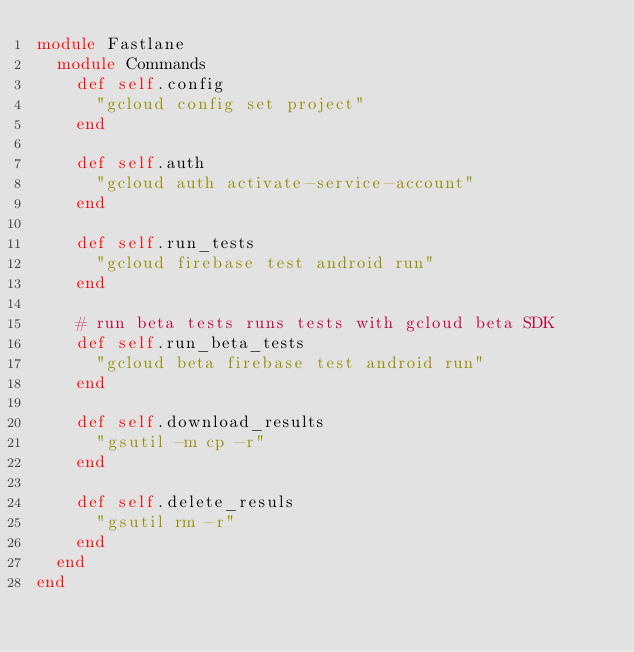Convert code to text. <code><loc_0><loc_0><loc_500><loc_500><_Ruby_>module Fastlane
  module Commands
    def self.config
      "gcloud config set project"
    end

    def self.auth
      "gcloud auth activate-service-account"
    end

    def self.run_tests
      "gcloud firebase test android run"
    end

    # run beta tests runs tests with gcloud beta SDK
    def self.run_beta_tests
      "gcloud beta firebase test android run"
    end

    def self.download_results
      "gsutil -m cp -r"
    end

    def self.delete_resuls
      "gsutil rm -r"
    end
  end
end
</code> 